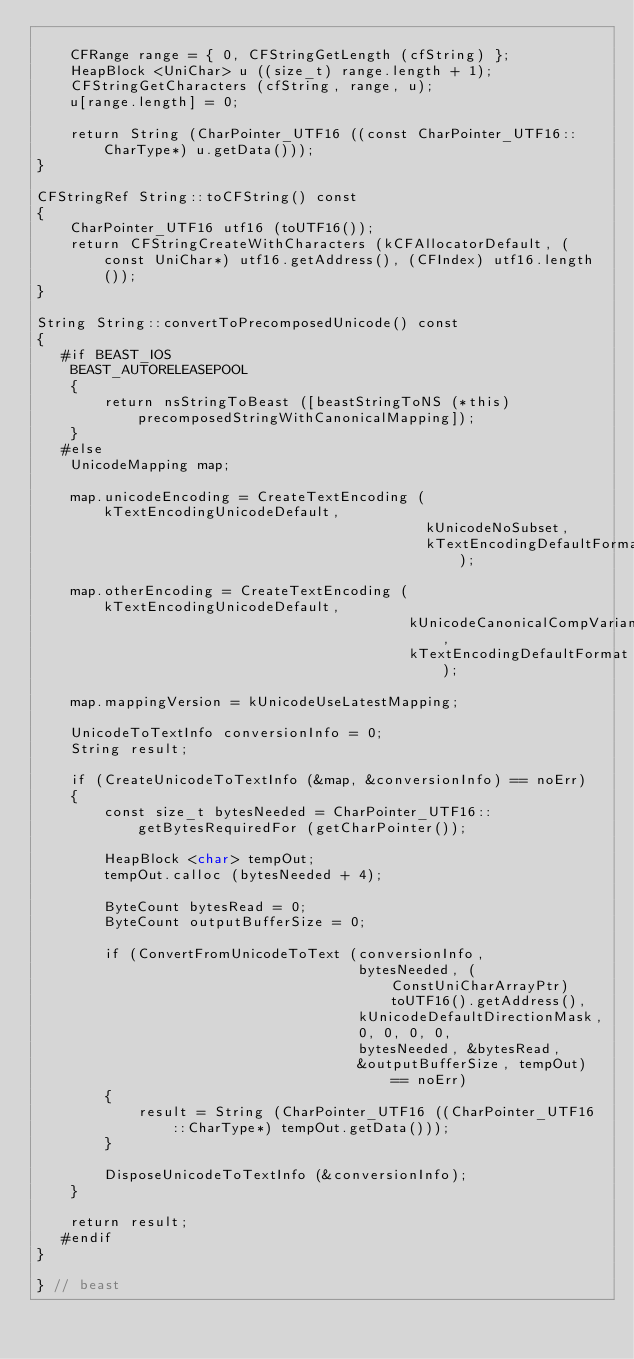<code> <loc_0><loc_0><loc_500><loc_500><_ObjectiveC_>
    CFRange range = { 0, CFStringGetLength (cfString) };
    HeapBlock <UniChar> u ((size_t) range.length + 1);
    CFStringGetCharacters (cfString, range, u);
    u[range.length] = 0;

    return String (CharPointer_UTF16 ((const CharPointer_UTF16::CharType*) u.getData()));
}

CFStringRef String::toCFString() const
{
    CharPointer_UTF16 utf16 (toUTF16());
    return CFStringCreateWithCharacters (kCFAllocatorDefault, (const UniChar*) utf16.getAddress(), (CFIndex) utf16.length());
}

String String::convertToPrecomposedUnicode() const
{
   #if BEAST_IOS
    BEAST_AUTORELEASEPOOL
    {
        return nsStringToBeast ([beastStringToNS (*this) precomposedStringWithCanonicalMapping]);
    }
   #else
    UnicodeMapping map;

    map.unicodeEncoding = CreateTextEncoding (kTextEncodingUnicodeDefault,
                                              kUnicodeNoSubset,
                                              kTextEncodingDefaultFormat);

    map.otherEncoding = CreateTextEncoding (kTextEncodingUnicodeDefault,
                                            kUnicodeCanonicalCompVariant,
                                            kTextEncodingDefaultFormat);

    map.mappingVersion = kUnicodeUseLatestMapping;

    UnicodeToTextInfo conversionInfo = 0;
    String result;

    if (CreateUnicodeToTextInfo (&map, &conversionInfo) == noErr)
    {
        const size_t bytesNeeded = CharPointer_UTF16::getBytesRequiredFor (getCharPointer());

        HeapBlock <char> tempOut;
        tempOut.calloc (bytesNeeded + 4);

        ByteCount bytesRead = 0;
        ByteCount outputBufferSize = 0;

        if (ConvertFromUnicodeToText (conversionInfo,
                                      bytesNeeded, (ConstUniCharArrayPtr) toUTF16().getAddress(),
                                      kUnicodeDefaultDirectionMask,
                                      0, 0, 0, 0,
                                      bytesNeeded, &bytesRead,
                                      &outputBufferSize, tempOut) == noErr)
        {
            result = String (CharPointer_UTF16 ((CharPointer_UTF16::CharType*) tempOut.getData()));
        }

        DisposeUnicodeToTextInfo (&conversionInfo);
    }

    return result;
   #endif
}

} // beast
</code> 